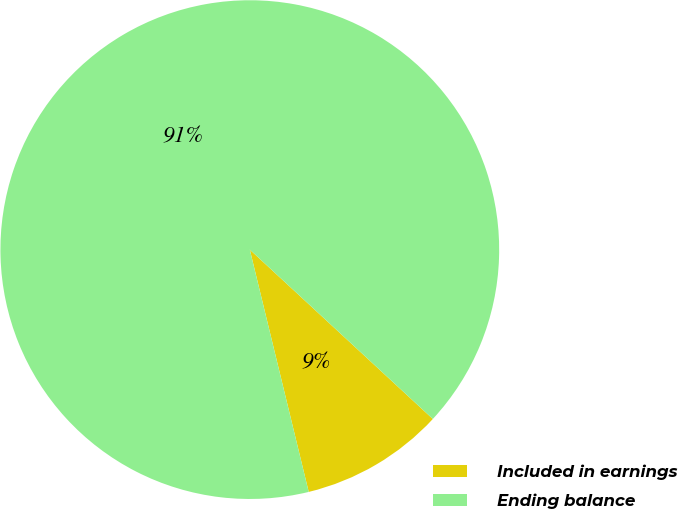Convert chart. <chart><loc_0><loc_0><loc_500><loc_500><pie_chart><fcel>Included in earnings<fcel>Ending balance<nl><fcel>9.32%<fcel>90.68%<nl></chart> 